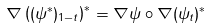<formula> <loc_0><loc_0><loc_500><loc_500>\nabla \left ( ( \psi ^ { * } ) _ { 1 - t } \right ) ^ { * } = \nabla \psi \circ \nabla ( \psi _ { t } ) ^ { * }</formula> 